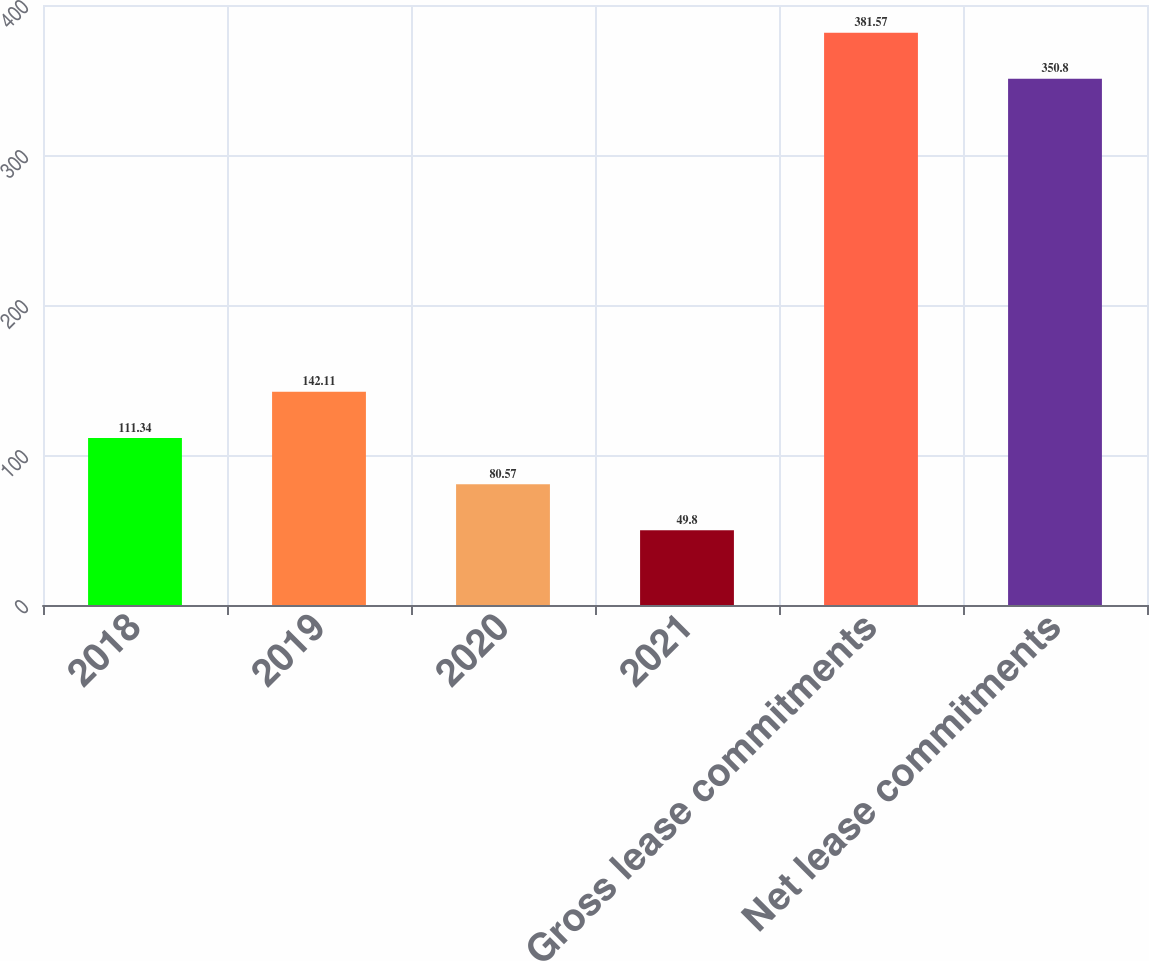<chart> <loc_0><loc_0><loc_500><loc_500><bar_chart><fcel>2018<fcel>2019<fcel>2020<fcel>2021<fcel>Gross lease commitments<fcel>Net lease commitments<nl><fcel>111.34<fcel>142.11<fcel>80.57<fcel>49.8<fcel>381.57<fcel>350.8<nl></chart> 